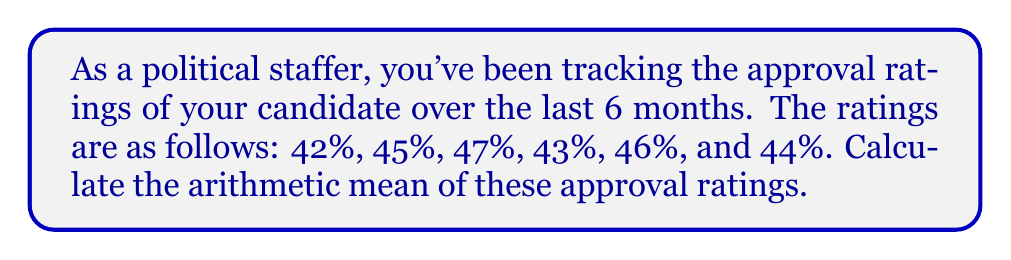What is the answer to this math problem? To find the arithmetic mean, we follow these steps:

1. Sum up all the values:
   $$42 + 45 + 47 + 43 + 46 + 44 = 267$$

2. Count the total number of values:
   There are 6 ratings.

3. Divide the sum by the total number of values:
   $$\text{Arithmetic Mean} = \frac{\text{Sum of Values}}{\text{Number of Values}}$$
   $$= \frac{267}{6}$$
   $$= 44.5$$

Therefore, the arithmetic mean of the approval ratings is 44.5%.
Answer: 44.5% 